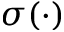Convert formula to latex. <formula><loc_0><loc_0><loc_500><loc_500>\sigma ( \cdot )</formula> 